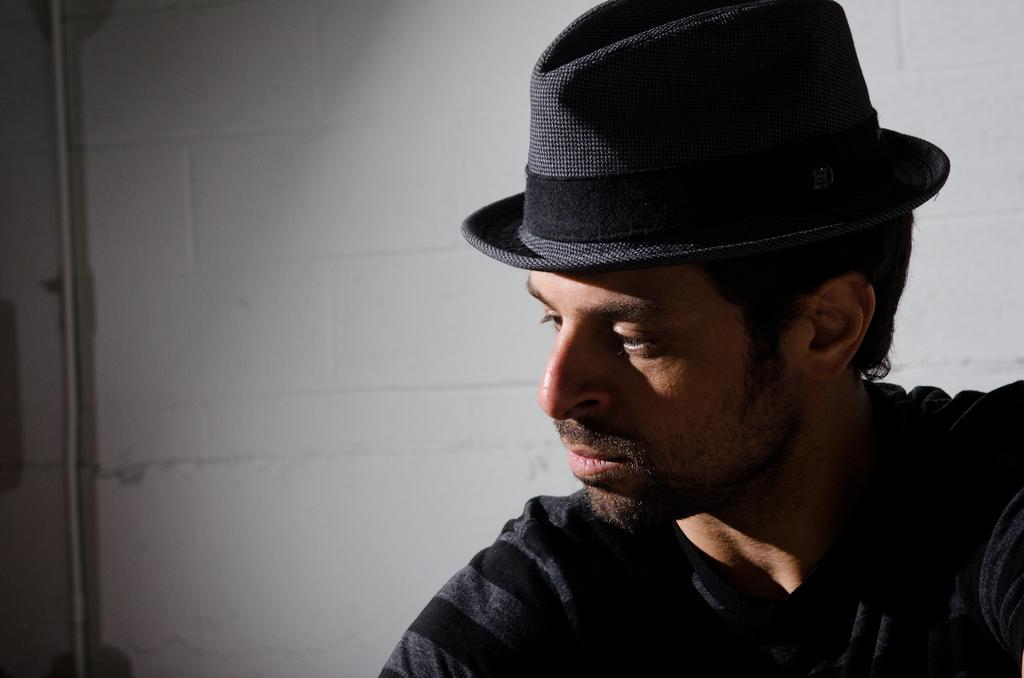Who is present in the image? There is a man in the image. What is the man wearing on his head? The man is wearing a cap. On which side of the image is the man located? The man is on the right side of the image. What can be seen in the background of the image? There is a rod and a wall in the background of the image. What type of popcorn is the monkey eating in the image? There is no monkey or popcorn present in the image. What is the porter carrying in the image? There is no porter present in the image. 